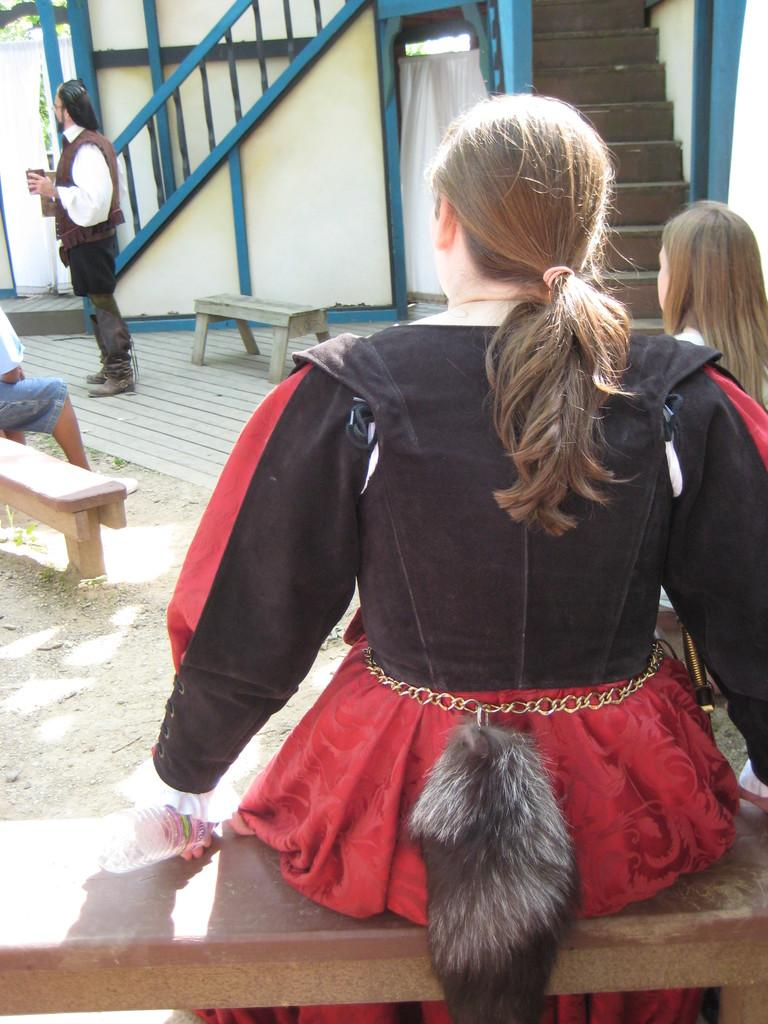What are the people in the image doing? There are persons sitting on a bench, and one person is standing. What architectural feature can be seen in the image? There are staircases visible in the image. What type of structure is present in the image? There is a wall in the image. What type of window treatment is present in the image? There is a curtain in the image. How many ants can be seen carrying weights on the dock in the image? There are no ants or docks present in the image. 